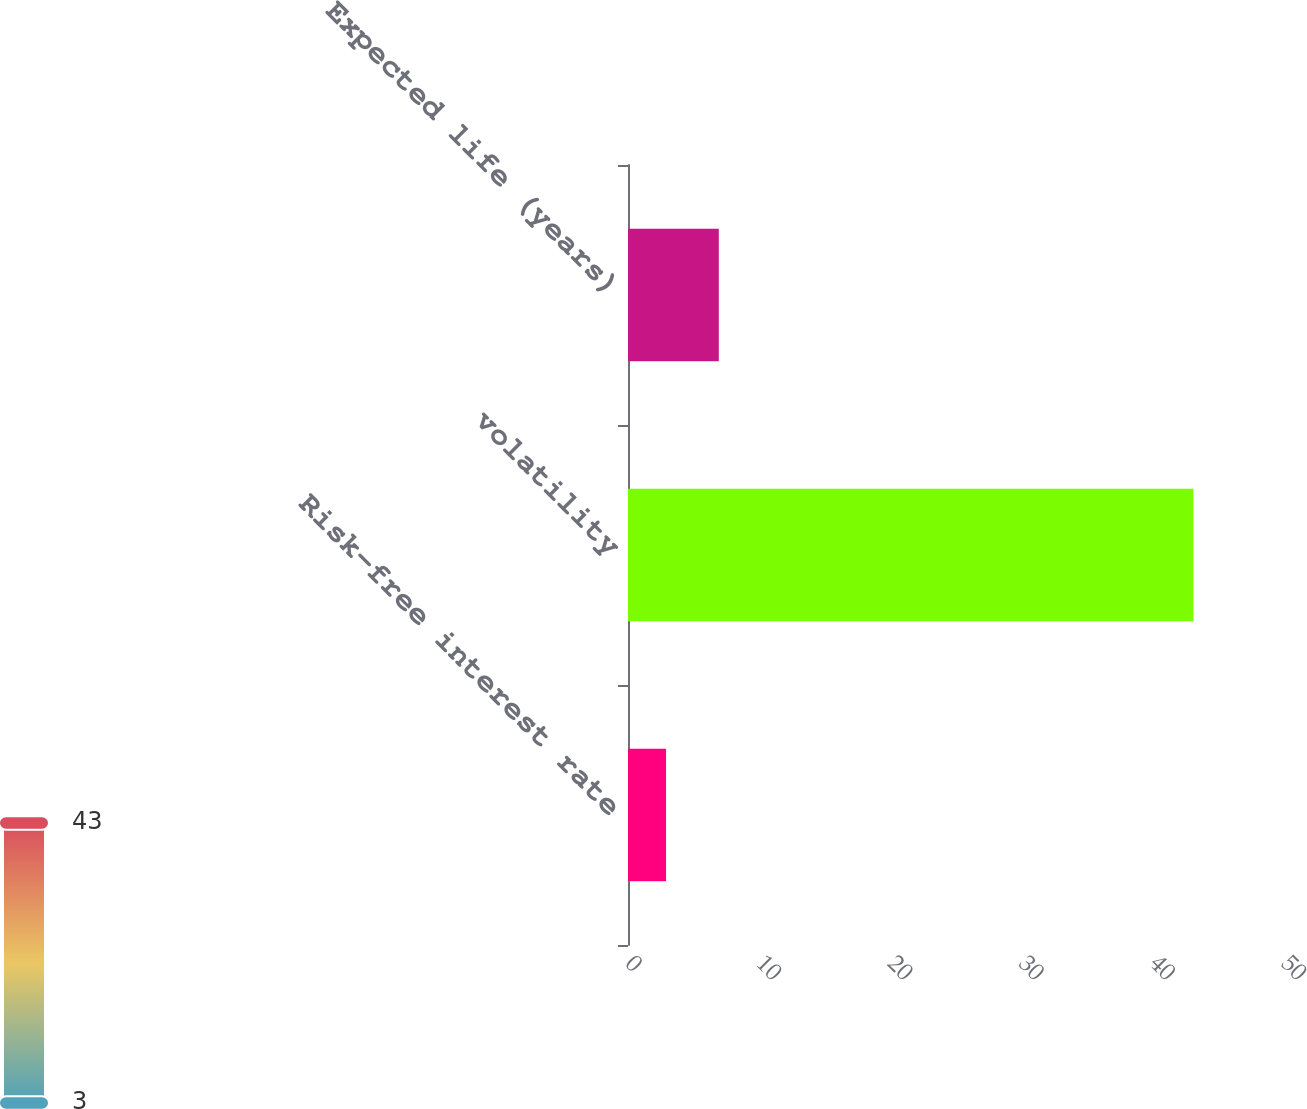Convert chart. <chart><loc_0><loc_0><loc_500><loc_500><bar_chart><fcel>Risk-free interest rate<fcel>volatility<fcel>Expected life (years)<nl><fcel>2.9<fcel>43.1<fcel>6.92<nl></chart> 